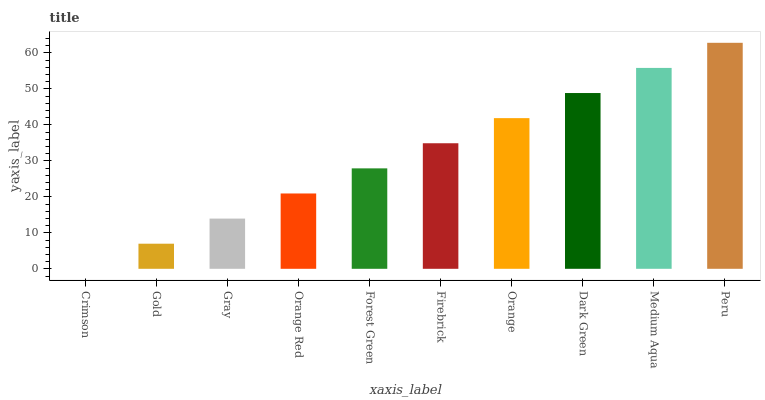Is Crimson the minimum?
Answer yes or no. Yes. Is Peru the maximum?
Answer yes or no. Yes. Is Gold the minimum?
Answer yes or no. No. Is Gold the maximum?
Answer yes or no. No. Is Gold greater than Crimson?
Answer yes or no. Yes. Is Crimson less than Gold?
Answer yes or no. Yes. Is Crimson greater than Gold?
Answer yes or no. No. Is Gold less than Crimson?
Answer yes or no. No. Is Firebrick the high median?
Answer yes or no. Yes. Is Forest Green the low median?
Answer yes or no. Yes. Is Forest Green the high median?
Answer yes or no. No. Is Gold the low median?
Answer yes or no. No. 